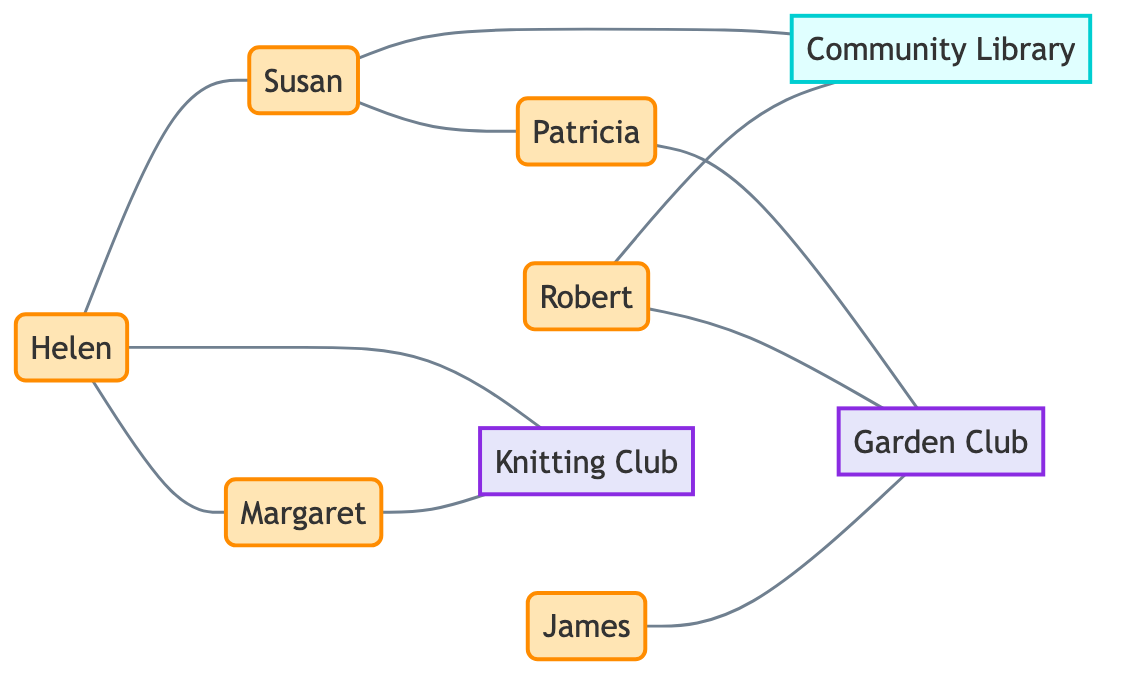What is the total number of nodes in the graph? To find the total number of nodes, we count each unique item listed under "nodes" in the data. The nodes are Helen, Margaret, Susan, Patricia, Robert, James, Knitting Club, Garden Club, and Community Library. This gives us a total of 9 nodes.
Answer: 9 Who is directly connected to Susan? To identify who is directly connected to Susan, we look at the edges that start or end with "Susan". The edges show that Susan is connected to Helen, Patricia, and the Community Library.
Answer: Helen, Patricia, Community Library Which club does Robert belong to? To determine which club Robert is part of, we check the edges connected to "Robert". The edges show that Robert is connected to the Garden Club and the Community Library. Since he is linked to the Garden Club, we conclude that he belongs to it.
Answer: Garden Club How many edges are there in total? To find the total number of edges, we count each connection listed under "edges". Each unique connection Identified in the edges indicates a relationship or friendship. There are 9 edges in total shown in the data.
Answer: 9 Is there any person associated with the Community Library? To check if any person is associated with the Community Library, we look for edges that connect "Library" to a person node. The data shows that both Susan and Robert have edges connecting them to the Community Library.
Answer: Yes How many people are directly connected to the Knitting Club? To find the number of people connected to the Knitting Club, we examine the edges where "Knitting Club" is involved. The relevant edges show that both Helen and Margaret are connected to the Knitting Club. Thus, there are 2 people associated with it.
Answer: 2 Which person is linked to both the Garden Club and the Community Library? We review the edges to see connections involving both the Garden Club and the Community Library. Robert is connected to the Garden Club and also has an edge to the Community Library, which confirms that he is linked to both.
Answer: Robert What is the relationship between Helen and Margaret? To establish the relationship between Helen and Margaret, we check for a direct edge connecting them in the diagram. An edge exists that connects Helen and Margaret, indicating a friendship.
Answer: Friendship 